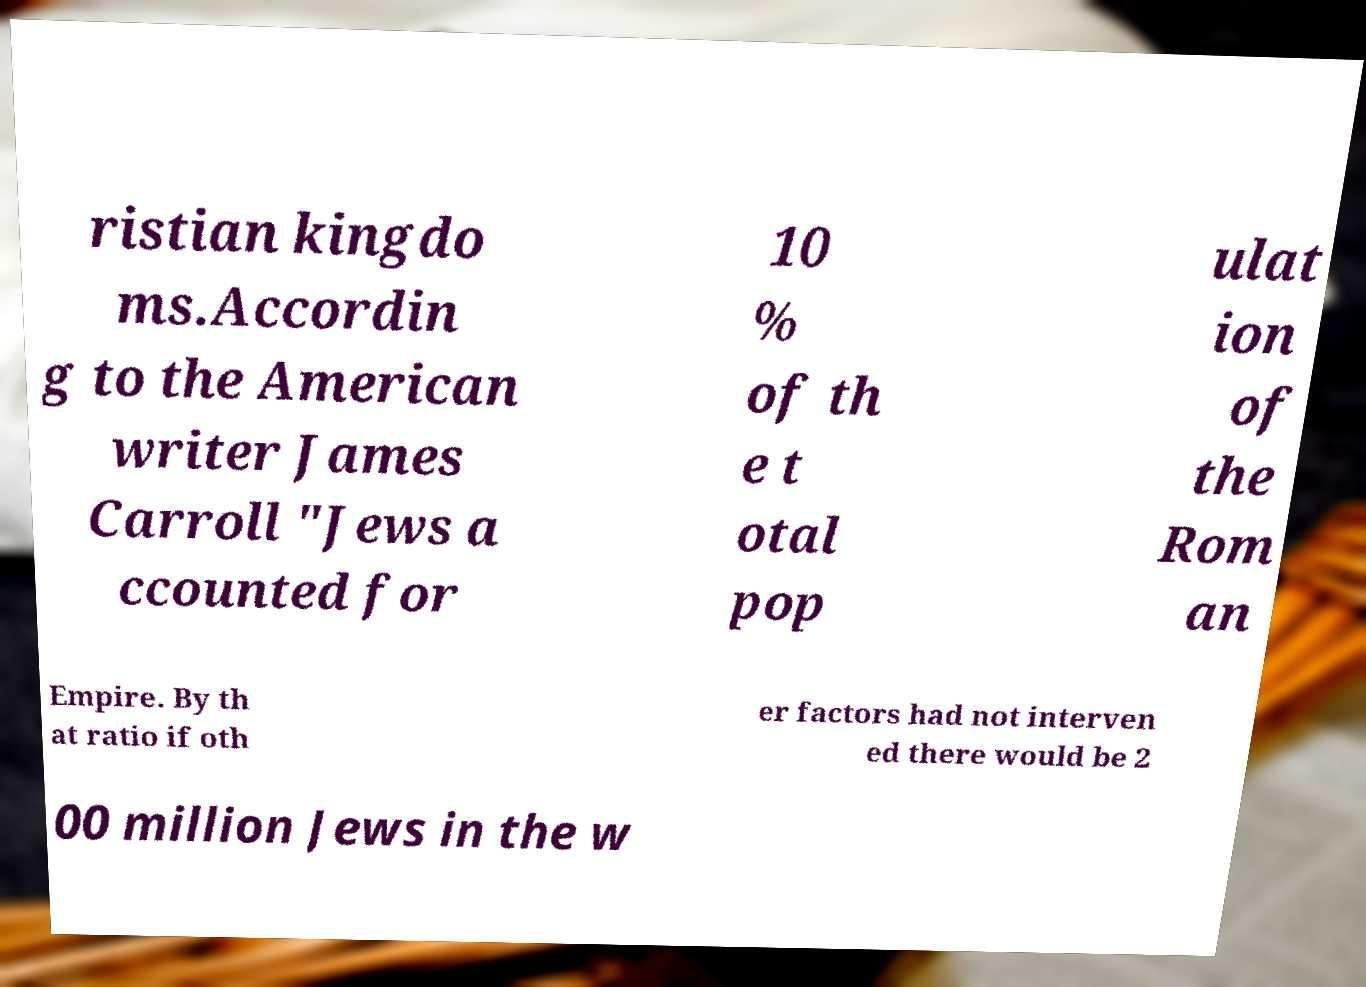What messages or text are displayed in this image? I need them in a readable, typed format. ristian kingdo ms.Accordin g to the American writer James Carroll "Jews a ccounted for 10 % of th e t otal pop ulat ion of the Rom an Empire. By th at ratio if oth er factors had not interven ed there would be 2 00 million Jews in the w 